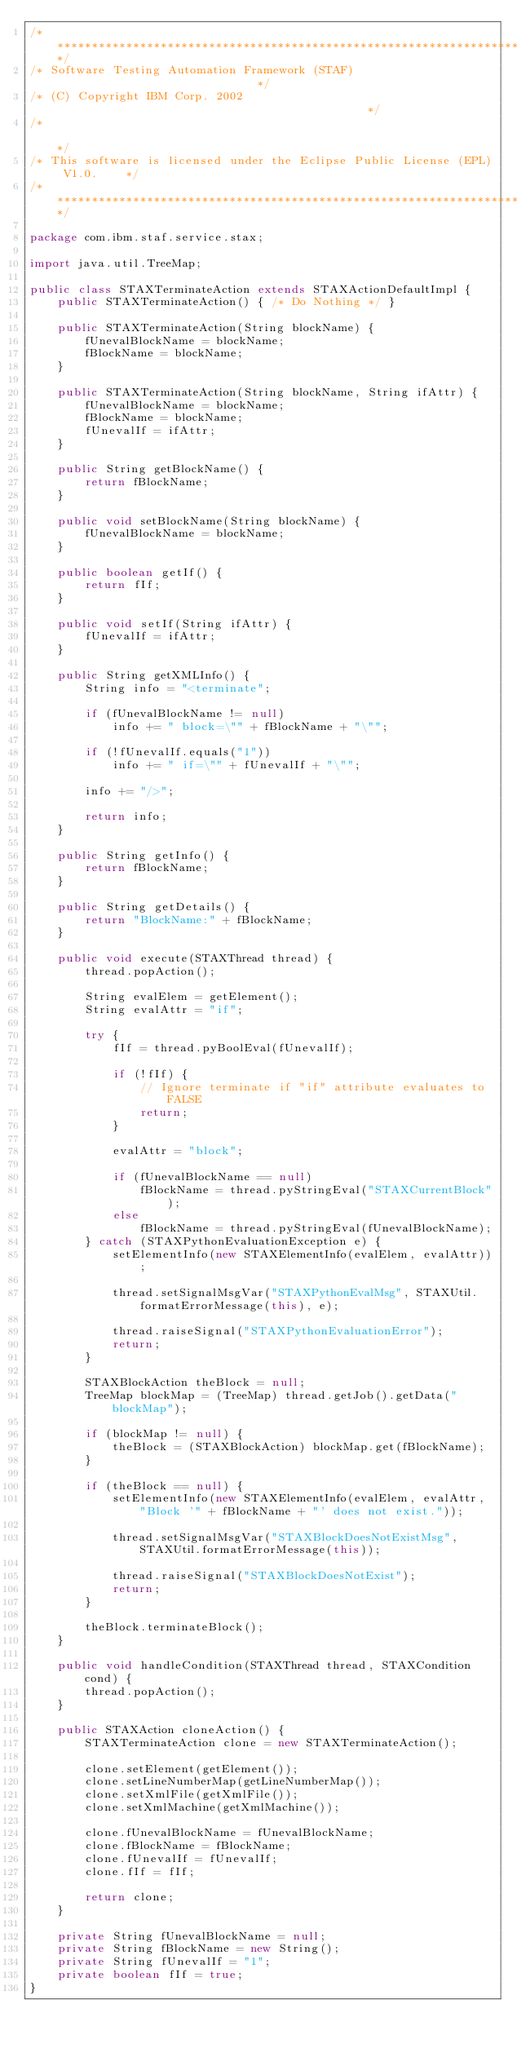<code> <loc_0><loc_0><loc_500><loc_500><_Java_>/*****************************************************************************/
/* Software Testing Automation Framework (STAF)                              */
/* (C) Copyright IBM Corp. 2002                                              */
/*                                                                           */
/* This software is licensed under the Eclipse Public License (EPL) V1.0.    */
/*****************************************************************************/

package com.ibm.staf.service.stax;

import java.util.TreeMap;

public class STAXTerminateAction extends STAXActionDefaultImpl {
    public STAXTerminateAction() { /* Do Nothing */ }

    public STAXTerminateAction(String blockName) {
        fUnevalBlockName = blockName;
        fBlockName = blockName;
    }

    public STAXTerminateAction(String blockName, String ifAttr) {
        fUnevalBlockName = blockName;
        fBlockName = blockName;
        fUnevalIf = ifAttr;
    }

    public String getBlockName() {
        return fBlockName;
    }

    public void setBlockName(String blockName) {
        fUnevalBlockName = blockName;
    }

    public boolean getIf() {
        return fIf;
    }

    public void setIf(String ifAttr) {
        fUnevalIf = ifAttr;
    }

    public String getXMLInfo() {
        String info = "<terminate";

        if (fUnevalBlockName != null)
            info += " block=\"" + fBlockName + "\"";

        if (!fUnevalIf.equals("1"))
            info += " if=\"" + fUnevalIf + "\"";

        info += "/>";

        return info;
    }

    public String getInfo() {
        return fBlockName;
    }

    public String getDetails() {
        return "BlockName:" + fBlockName;
    }

    public void execute(STAXThread thread) {
        thread.popAction();

        String evalElem = getElement();
        String evalAttr = "if";

        try {
            fIf = thread.pyBoolEval(fUnevalIf);

            if (!fIf) {
                // Ignore terminate if "if" attribute evaluates to FALSE
                return;
            }

            evalAttr = "block";

            if (fUnevalBlockName == null)
                fBlockName = thread.pyStringEval("STAXCurrentBlock");
            else
                fBlockName = thread.pyStringEval(fUnevalBlockName);
        } catch (STAXPythonEvaluationException e) {
            setElementInfo(new STAXElementInfo(evalElem, evalAttr));

            thread.setSignalMsgVar("STAXPythonEvalMsg", STAXUtil.formatErrorMessage(this), e);

            thread.raiseSignal("STAXPythonEvaluationError");
            return;
        }

        STAXBlockAction theBlock = null;
        TreeMap blockMap = (TreeMap) thread.getJob().getData("blockMap");

        if (blockMap != null) {
            theBlock = (STAXBlockAction) blockMap.get(fBlockName);
        }

        if (theBlock == null) {
            setElementInfo(new STAXElementInfo(evalElem, evalAttr, "Block '" + fBlockName + "' does not exist."));

            thread.setSignalMsgVar("STAXBlockDoesNotExistMsg", STAXUtil.formatErrorMessage(this));

            thread.raiseSignal("STAXBlockDoesNotExist");
            return;
        }

        theBlock.terminateBlock();
    }

    public void handleCondition(STAXThread thread, STAXCondition cond) {
        thread.popAction();
    }

    public STAXAction cloneAction() {
        STAXTerminateAction clone = new STAXTerminateAction();

        clone.setElement(getElement());
        clone.setLineNumberMap(getLineNumberMap());
        clone.setXmlFile(getXmlFile());
        clone.setXmlMachine(getXmlMachine());

        clone.fUnevalBlockName = fUnevalBlockName;
        clone.fBlockName = fBlockName;
        clone.fUnevalIf = fUnevalIf;
        clone.fIf = fIf;

        return clone;
    }

    private String fUnevalBlockName = null;
    private String fBlockName = new String();
    private String fUnevalIf = "1";
    private boolean fIf = true;
}
</code> 